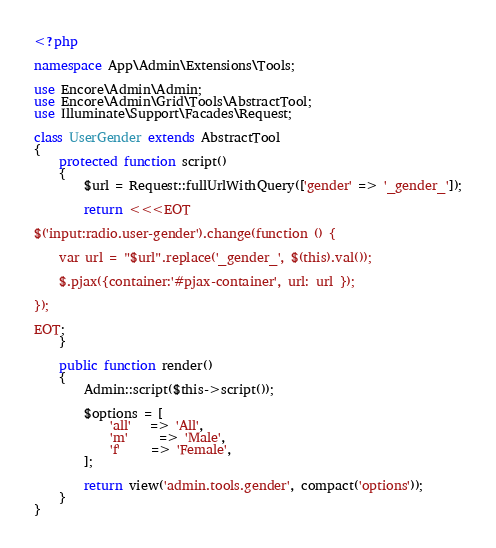Convert code to text. <code><loc_0><loc_0><loc_500><loc_500><_PHP_><?php

namespace App\Admin\Extensions\Tools;

use Encore\Admin\Admin;
use Encore\Admin\Grid\Tools\AbstractTool;
use Illuminate\Support\Facades\Request;

class UserGender extends AbstractTool
{
    protected function script()
    {
        $url = Request::fullUrlWithQuery(['gender' => '_gender_']);

        return <<<EOT
    
$('input:radio.user-gender').change(function () {

    var url = "$url".replace('_gender_', $(this).val());

    $.pjax({container:'#pjax-container', url: url });

});

EOT;
    }

    public function render()
    {
        Admin::script($this->script());

        $options = [
            'all'   => 'All',
            'm'     => 'Male',
            'f'     => 'Female',
        ];

        return view('admin.tools.gender', compact('options'));
    }
}</code> 